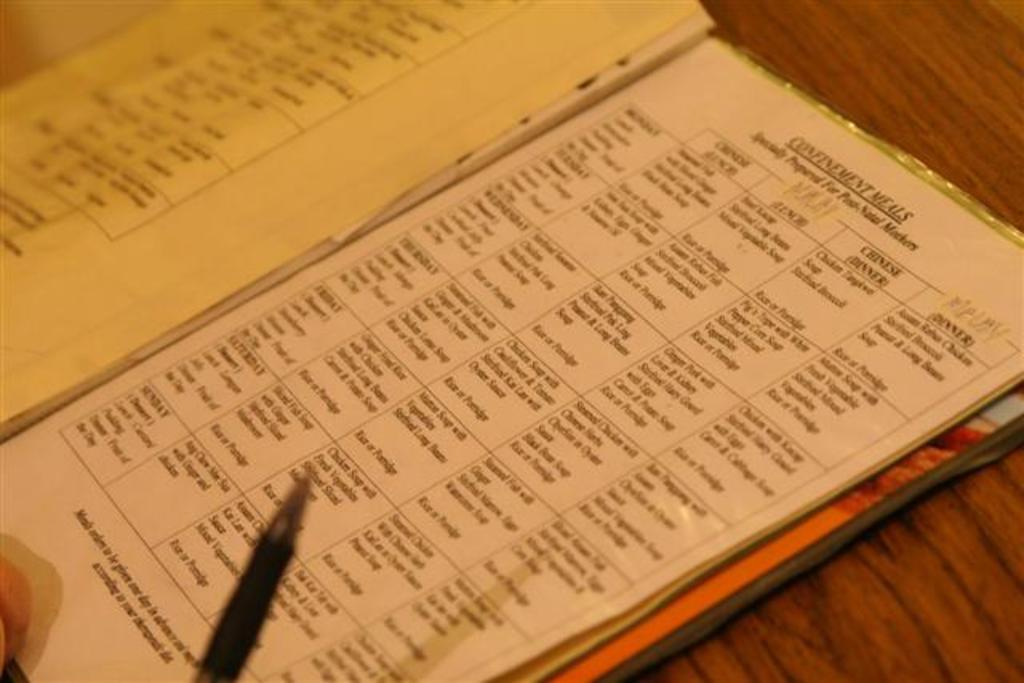What type of meals are these?
Provide a short and direct response. Confinement meals. Who are these meals prepared for?
Give a very brief answer. Unanswerable. 